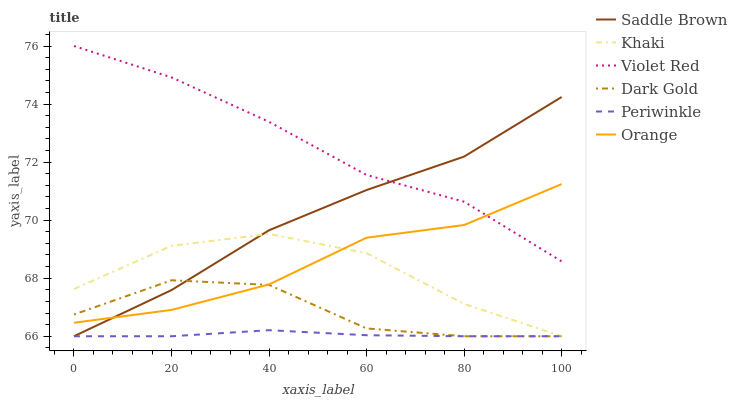Does Periwinkle have the minimum area under the curve?
Answer yes or no. Yes. Does Violet Red have the maximum area under the curve?
Answer yes or no. Yes. Does Khaki have the minimum area under the curve?
Answer yes or no. No. Does Khaki have the maximum area under the curve?
Answer yes or no. No. Is Periwinkle the smoothest?
Answer yes or no. Yes. Is Dark Gold the roughest?
Answer yes or no. Yes. Is Khaki the smoothest?
Answer yes or no. No. Is Khaki the roughest?
Answer yes or no. No. Does Khaki have the lowest value?
Answer yes or no. Yes. Does Orange have the lowest value?
Answer yes or no. No. Does Violet Red have the highest value?
Answer yes or no. Yes. Does Khaki have the highest value?
Answer yes or no. No. Is Periwinkle less than Orange?
Answer yes or no. Yes. Is Violet Red greater than Khaki?
Answer yes or no. Yes. Does Periwinkle intersect Khaki?
Answer yes or no. Yes. Is Periwinkle less than Khaki?
Answer yes or no. No. Is Periwinkle greater than Khaki?
Answer yes or no. No. Does Periwinkle intersect Orange?
Answer yes or no. No. 